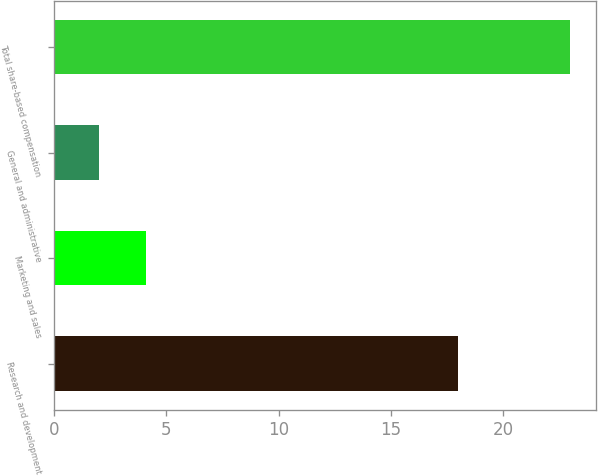Convert chart to OTSL. <chart><loc_0><loc_0><loc_500><loc_500><bar_chart><fcel>Research and development<fcel>Marketing and sales<fcel>General and administrative<fcel>Total share-based compensation<nl><fcel>18<fcel>4.1<fcel>2<fcel>23<nl></chart> 